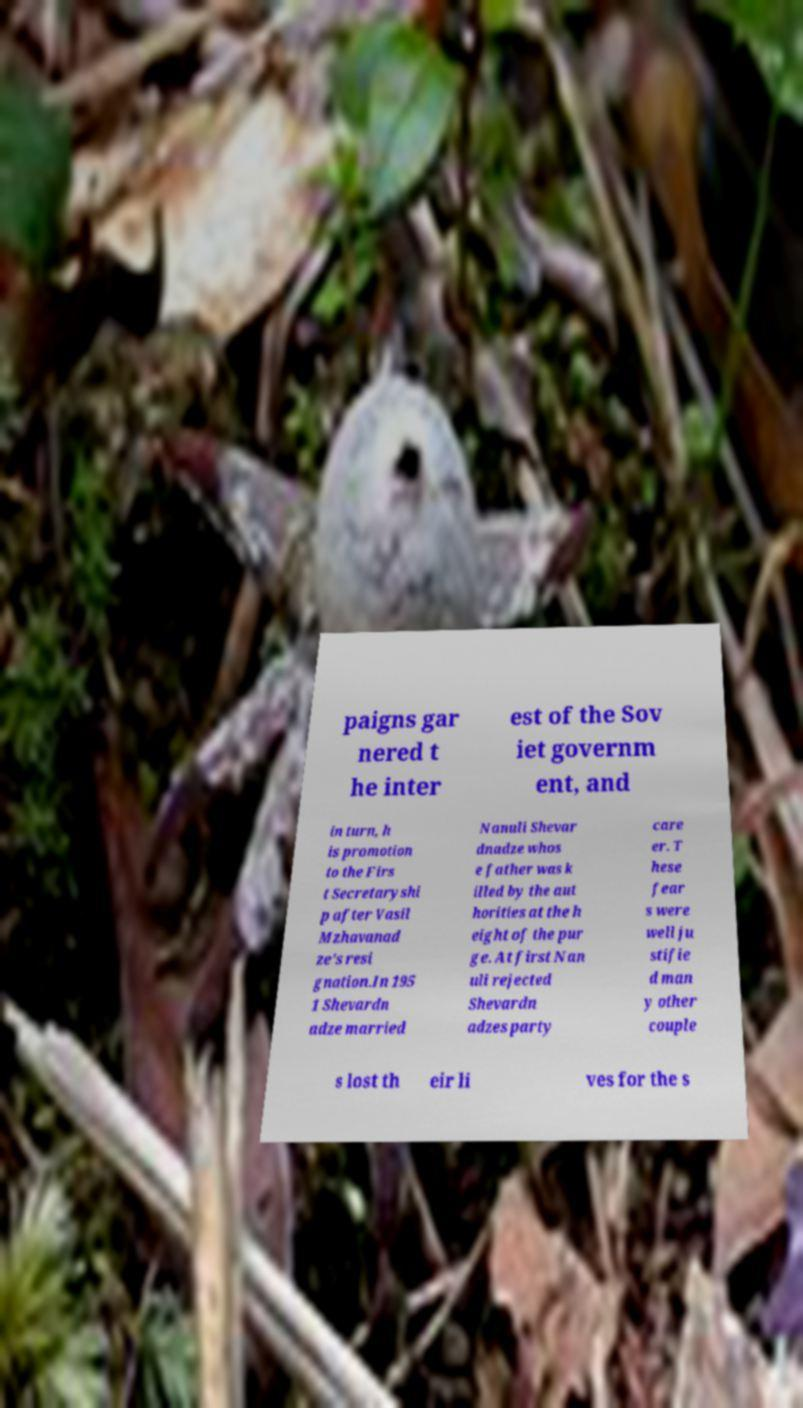Please identify and transcribe the text found in this image. paigns gar nered t he inter est of the Sov iet governm ent, and in turn, h is promotion to the Firs t Secretaryshi p after Vasil Mzhavanad ze's resi gnation.In 195 1 Shevardn adze married Nanuli Shevar dnadze whos e father was k illed by the aut horities at the h eight of the pur ge. At first Nan uli rejected Shevardn adzes party care er. T hese fear s were well ju stifie d man y other couple s lost th eir li ves for the s 